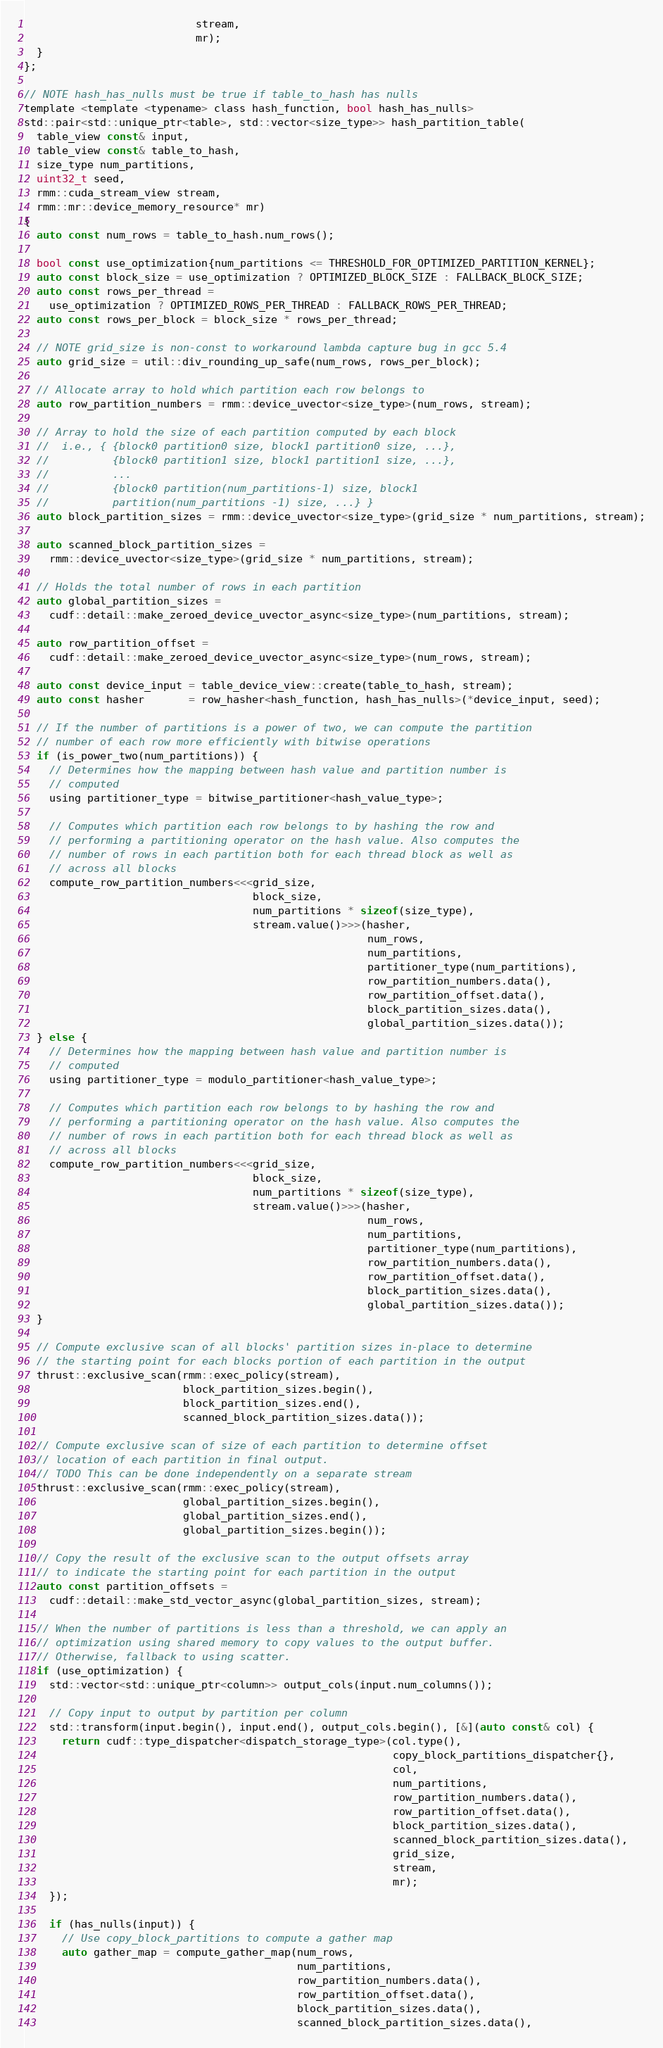Convert code to text. <code><loc_0><loc_0><loc_500><loc_500><_Cuda_>                           stream,
                           mr);
  }
};

// NOTE hash_has_nulls must be true if table_to_hash has nulls
template <template <typename> class hash_function, bool hash_has_nulls>
std::pair<std::unique_ptr<table>, std::vector<size_type>> hash_partition_table(
  table_view const& input,
  table_view const& table_to_hash,
  size_type num_partitions,
  uint32_t seed,
  rmm::cuda_stream_view stream,
  rmm::mr::device_memory_resource* mr)
{
  auto const num_rows = table_to_hash.num_rows();

  bool const use_optimization{num_partitions <= THRESHOLD_FOR_OPTIMIZED_PARTITION_KERNEL};
  auto const block_size = use_optimization ? OPTIMIZED_BLOCK_SIZE : FALLBACK_BLOCK_SIZE;
  auto const rows_per_thread =
    use_optimization ? OPTIMIZED_ROWS_PER_THREAD : FALLBACK_ROWS_PER_THREAD;
  auto const rows_per_block = block_size * rows_per_thread;

  // NOTE grid_size is non-const to workaround lambda capture bug in gcc 5.4
  auto grid_size = util::div_rounding_up_safe(num_rows, rows_per_block);

  // Allocate array to hold which partition each row belongs to
  auto row_partition_numbers = rmm::device_uvector<size_type>(num_rows, stream);

  // Array to hold the size of each partition computed by each block
  //  i.e., { {block0 partition0 size, block1 partition0 size, ...},
  //          {block0 partition1 size, block1 partition1 size, ...},
  //          ...
  //          {block0 partition(num_partitions-1) size, block1
  //          partition(num_partitions -1) size, ...} }
  auto block_partition_sizes = rmm::device_uvector<size_type>(grid_size * num_partitions, stream);

  auto scanned_block_partition_sizes =
    rmm::device_uvector<size_type>(grid_size * num_partitions, stream);

  // Holds the total number of rows in each partition
  auto global_partition_sizes =
    cudf::detail::make_zeroed_device_uvector_async<size_type>(num_partitions, stream);

  auto row_partition_offset =
    cudf::detail::make_zeroed_device_uvector_async<size_type>(num_rows, stream);

  auto const device_input = table_device_view::create(table_to_hash, stream);
  auto const hasher       = row_hasher<hash_function, hash_has_nulls>(*device_input, seed);

  // If the number of partitions is a power of two, we can compute the partition
  // number of each row more efficiently with bitwise operations
  if (is_power_two(num_partitions)) {
    // Determines how the mapping between hash value and partition number is
    // computed
    using partitioner_type = bitwise_partitioner<hash_value_type>;

    // Computes which partition each row belongs to by hashing the row and
    // performing a partitioning operator on the hash value. Also computes the
    // number of rows in each partition both for each thread block as well as
    // across all blocks
    compute_row_partition_numbers<<<grid_size,
                                    block_size,
                                    num_partitions * sizeof(size_type),
                                    stream.value()>>>(hasher,
                                                      num_rows,
                                                      num_partitions,
                                                      partitioner_type(num_partitions),
                                                      row_partition_numbers.data(),
                                                      row_partition_offset.data(),
                                                      block_partition_sizes.data(),
                                                      global_partition_sizes.data());
  } else {
    // Determines how the mapping between hash value and partition number is
    // computed
    using partitioner_type = modulo_partitioner<hash_value_type>;

    // Computes which partition each row belongs to by hashing the row and
    // performing a partitioning operator on the hash value. Also computes the
    // number of rows in each partition both for each thread block as well as
    // across all blocks
    compute_row_partition_numbers<<<grid_size,
                                    block_size,
                                    num_partitions * sizeof(size_type),
                                    stream.value()>>>(hasher,
                                                      num_rows,
                                                      num_partitions,
                                                      partitioner_type(num_partitions),
                                                      row_partition_numbers.data(),
                                                      row_partition_offset.data(),
                                                      block_partition_sizes.data(),
                                                      global_partition_sizes.data());
  }

  // Compute exclusive scan of all blocks' partition sizes in-place to determine
  // the starting point for each blocks portion of each partition in the output
  thrust::exclusive_scan(rmm::exec_policy(stream),
                         block_partition_sizes.begin(),
                         block_partition_sizes.end(),
                         scanned_block_partition_sizes.data());

  // Compute exclusive scan of size of each partition to determine offset
  // location of each partition in final output.
  // TODO This can be done independently on a separate stream
  thrust::exclusive_scan(rmm::exec_policy(stream),
                         global_partition_sizes.begin(),
                         global_partition_sizes.end(),
                         global_partition_sizes.begin());

  // Copy the result of the exclusive scan to the output offsets array
  // to indicate the starting point for each partition in the output
  auto const partition_offsets =
    cudf::detail::make_std_vector_async(global_partition_sizes, stream);

  // When the number of partitions is less than a threshold, we can apply an
  // optimization using shared memory to copy values to the output buffer.
  // Otherwise, fallback to using scatter.
  if (use_optimization) {
    std::vector<std::unique_ptr<column>> output_cols(input.num_columns());

    // Copy input to output by partition per column
    std::transform(input.begin(), input.end(), output_cols.begin(), [&](auto const& col) {
      return cudf::type_dispatcher<dispatch_storage_type>(col.type(),
                                                          copy_block_partitions_dispatcher{},
                                                          col,
                                                          num_partitions,
                                                          row_partition_numbers.data(),
                                                          row_partition_offset.data(),
                                                          block_partition_sizes.data(),
                                                          scanned_block_partition_sizes.data(),
                                                          grid_size,
                                                          stream,
                                                          mr);
    });

    if (has_nulls(input)) {
      // Use copy_block_partitions to compute a gather map
      auto gather_map = compute_gather_map(num_rows,
                                           num_partitions,
                                           row_partition_numbers.data(),
                                           row_partition_offset.data(),
                                           block_partition_sizes.data(),
                                           scanned_block_partition_sizes.data(),</code> 